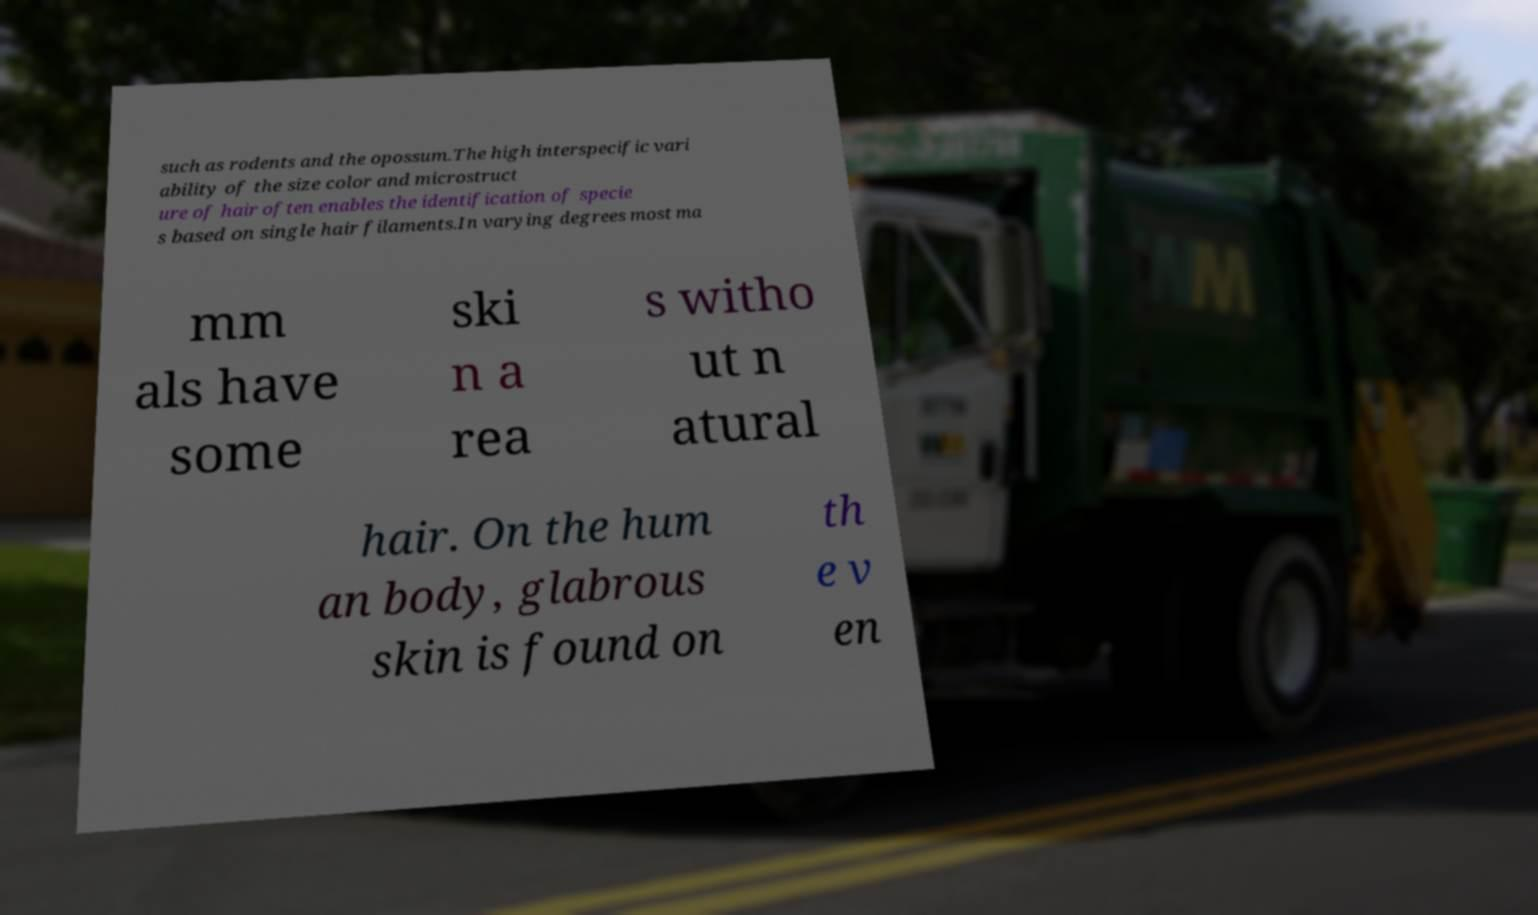Could you extract and type out the text from this image? such as rodents and the opossum.The high interspecific vari ability of the size color and microstruct ure of hair often enables the identification of specie s based on single hair filaments.In varying degrees most ma mm als have some ski n a rea s witho ut n atural hair. On the hum an body, glabrous skin is found on th e v en 